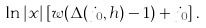<formula> <loc_0><loc_0><loc_500><loc_500>\ln | x | \left [ w ( \Delta ( j _ { 0 } , h ) - 1 ) + j _ { 0 } \right ] .</formula> 